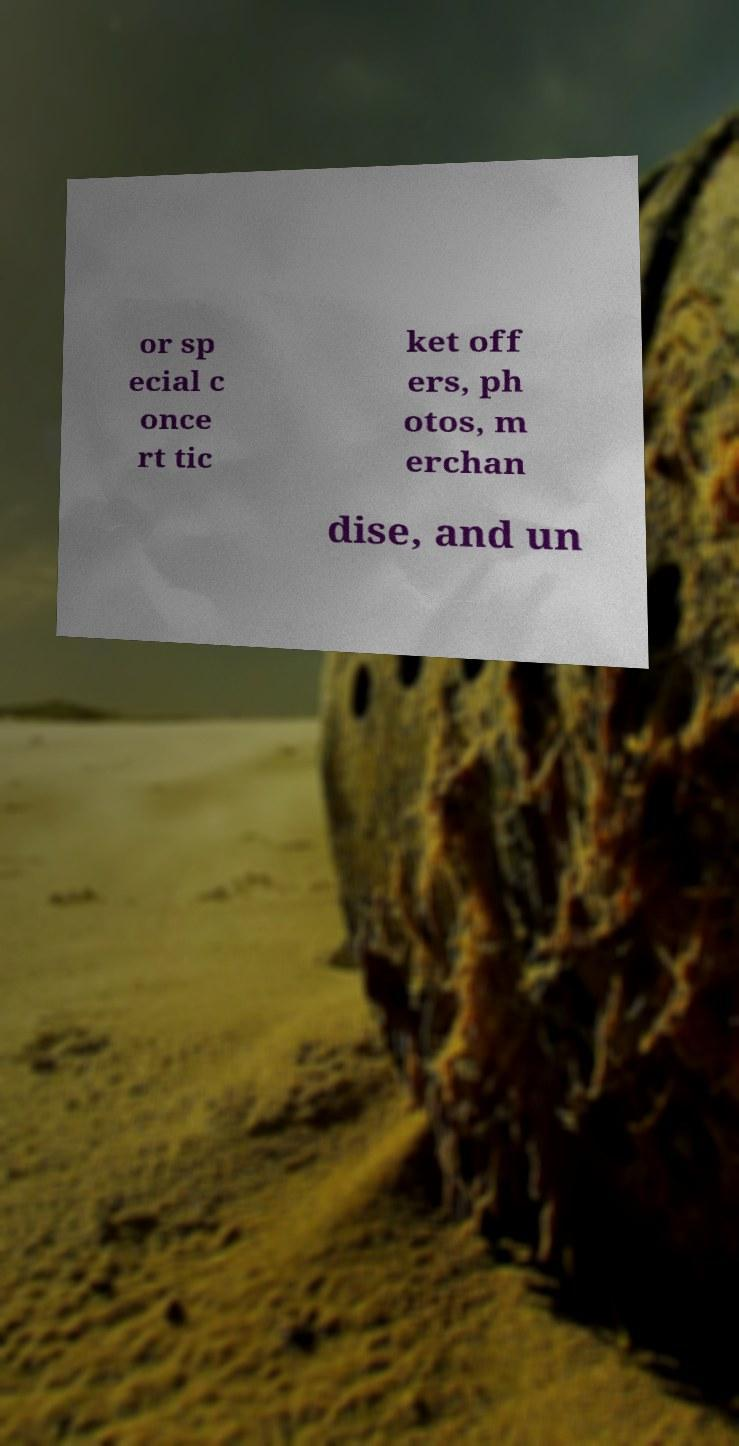For documentation purposes, I need the text within this image transcribed. Could you provide that? or sp ecial c once rt tic ket off ers, ph otos, m erchan dise, and un 